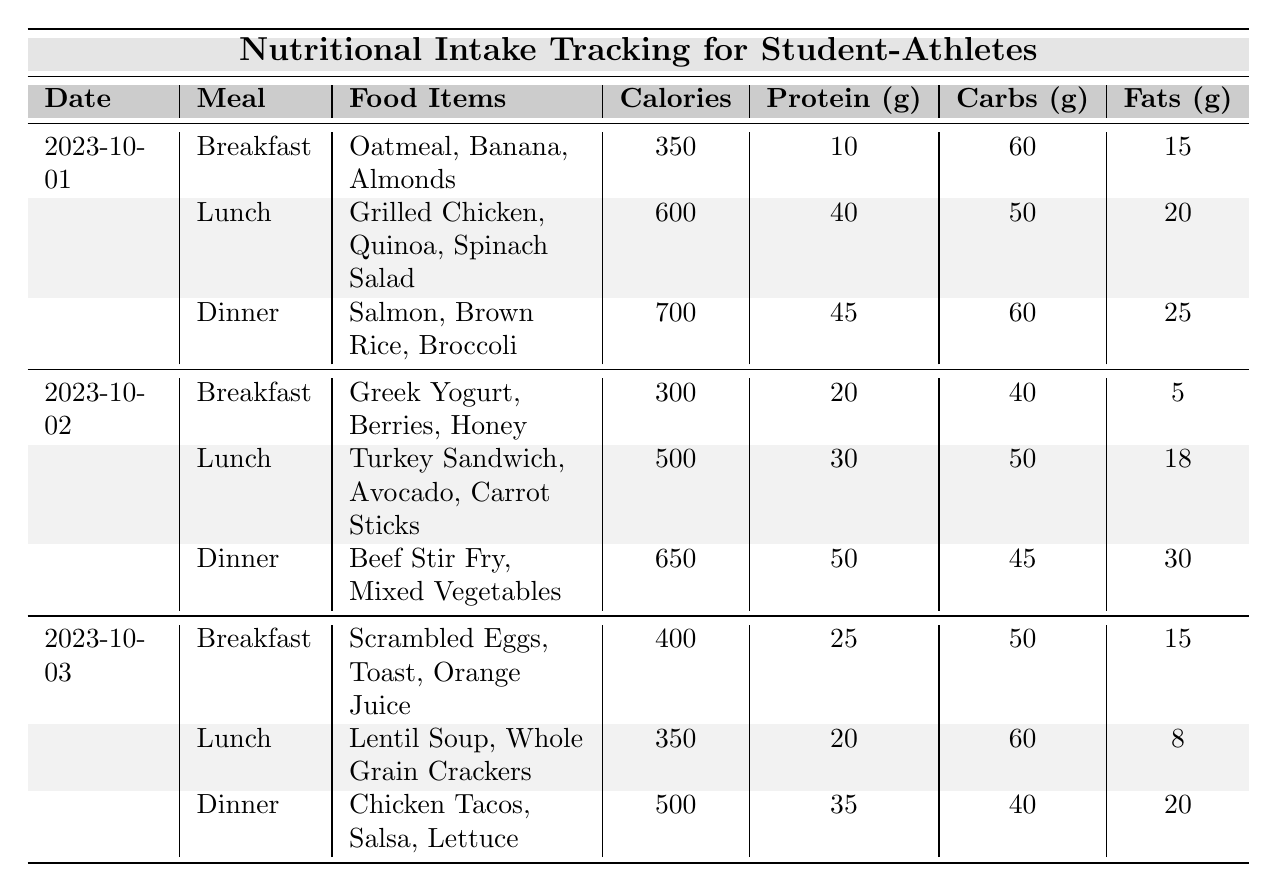What were the total calories consumed on October 1st? The meals consumed on October 1st are Breakfast (350 calories), Lunch (600 calories), and Dinner (700 calories). Summing these gives 350 + 600 + 700 = 1650 calories.
Answer: 1650 Which meal on October 2nd had the highest protein content? On October 2nd, the protein content for Breakfast is 20g, Lunch is 30g, and Dinner is 50g. The highest is Dinner with 50g of protein.
Answer: Dinner How many grams of fats were consumed in the Lunch on October 3rd? The Lunch on October 3rd consists of Lentil Soup and Whole Grain Crackers, which totals to 8 grams of fats.
Answer: 8 What is the total carbohydrate intake over the three days? On October 1st, the total carbs are 60 + 50 + 60 = 170g. On October 2nd, the total carbs are 40 + 50 + 45 = 135g. On October 3rd, the total carbs are 50 + 60 + 40 = 150g. Adding these groups results in 170 + 135 + 150 = 455g total carbohydrates.
Answer: 455 Did the Breakfast on October 1st provide more calories than the Breakfast on October 2nd? Breakfast on October 1st has 350 calories, and Breakfast on October 2nd has 300 calories. Since 350 is greater than 300, the statement is true.
Answer: Yes What was the average protein intake from all dinners over the three days? The protein values for dinner are: October 1st: 45g, October 2nd: 50g, October 3rd: 35g. Summing these gives 45 + 50 + 35 = 130g. Dividing by 3 meals gives an average of 130/3 ≈ 43.33g.
Answer: 43.33 Which food item was consumed at breakfast on October 3rd? The Breakfast meal on October 3rd consisted of Scrambled Eggs, Toast, and Orange Juice.
Answer: Scrambled Eggs, Toast, Orange Juice How many total fats were consumed on October 2nd? On October 2nd, the fats for Breakfast is 5g, Lunch is 18g, and Dinner is 30g. Summing these values gives 5 + 18 + 30 = 53g total fats for the day.
Answer: 53 Which day had the highest total calories consumed? The total calories for October 1st is 1650, for October 2nd is 1450 (300 + 500 + 650), and for October 3rd is 1250 (400 + 350 + 500). Thus, October 1st has the highest calories at 1650.
Answer: October 1st What food items were consumed for lunch on October 1st? The Lunch on October 1st consisted of Grilled Chicken, Quinoa, and Spinach Salad.
Answer: Grilled Chicken, Quinoa, Spinach Salad 